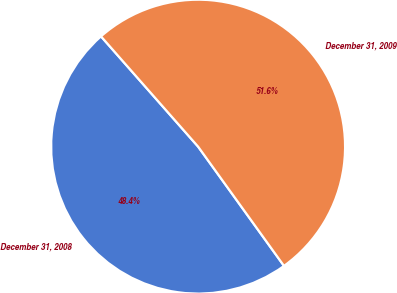Convert chart. <chart><loc_0><loc_0><loc_500><loc_500><pie_chart><fcel>December 31, 2008<fcel>December 31, 2009<nl><fcel>48.44%<fcel>51.56%<nl></chart> 